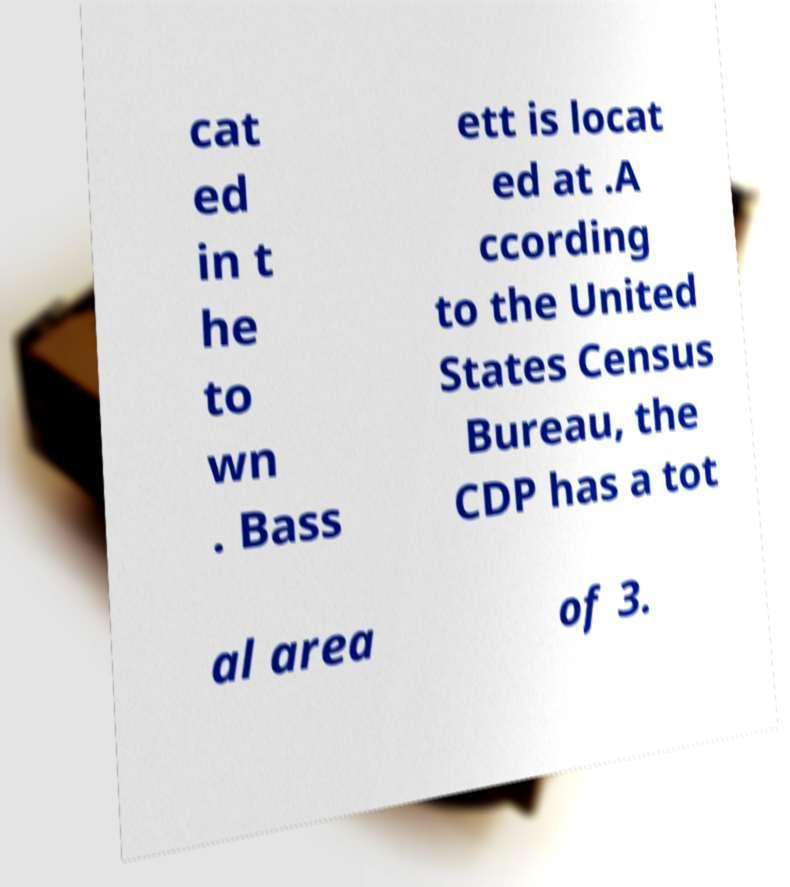There's text embedded in this image that I need extracted. Can you transcribe it verbatim? cat ed in t he to wn . Bass ett is locat ed at .A ccording to the United States Census Bureau, the CDP has a tot al area of 3. 